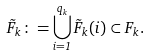<formula> <loc_0><loc_0><loc_500><loc_500>\tilde { F } _ { k } \colon = \bigcup _ { i = 1 } ^ { q _ { k } } \tilde { F } _ { k } ( i ) \subset F _ { k } .</formula> 